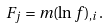<formula> <loc_0><loc_0><loc_500><loc_500>F _ { j } = m ( \ln f ) _ { , i } .</formula> 